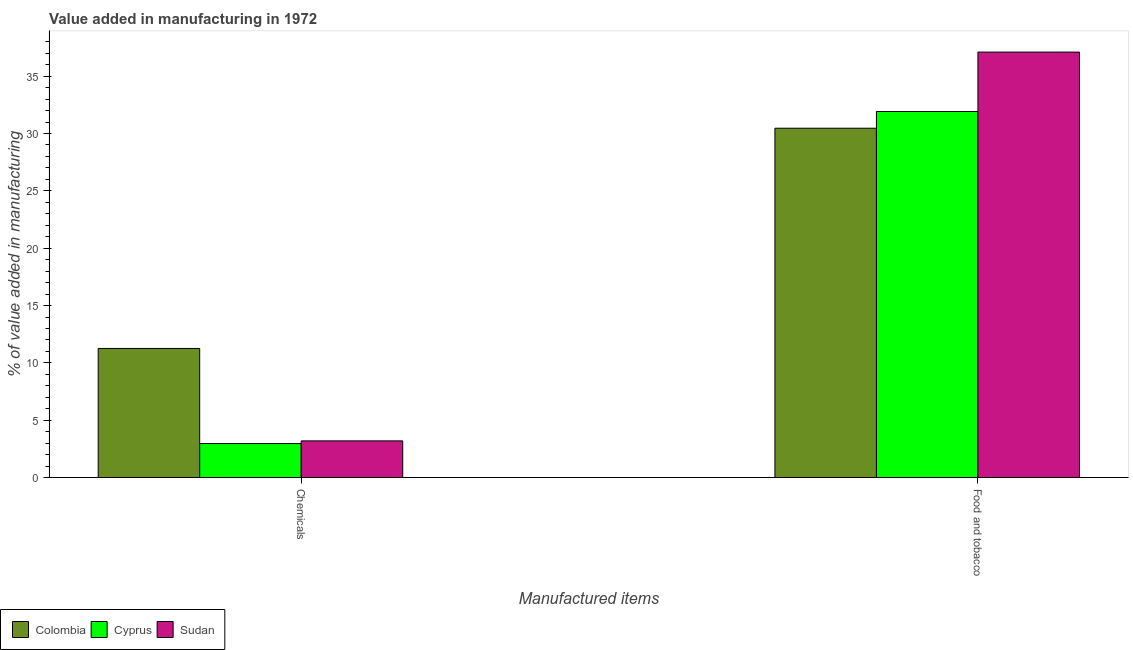How many different coloured bars are there?
Make the answer very short. 3. How many groups of bars are there?
Provide a short and direct response. 2. Are the number of bars on each tick of the X-axis equal?
Your answer should be very brief. Yes. What is the label of the 2nd group of bars from the left?
Offer a very short reply. Food and tobacco. What is the value added by  manufacturing chemicals in Colombia?
Offer a very short reply. 11.26. Across all countries, what is the maximum value added by  manufacturing chemicals?
Provide a succinct answer. 11.26. Across all countries, what is the minimum value added by  manufacturing chemicals?
Offer a very short reply. 2.96. In which country was the value added by manufacturing food and tobacco maximum?
Your answer should be very brief. Sudan. In which country was the value added by  manufacturing chemicals minimum?
Ensure brevity in your answer.  Cyprus. What is the total value added by  manufacturing chemicals in the graph?
Offer a terse response. 17.42. What is the difference between the value added by  manufacturing chemicals in Colombia and that in Sudan?
Give a very brief answer. 8.06. What is the difference between the value added by  manufacturing chemicals in Cyprus and the value added by manufacturing food and tobacco in Sudan?
Your answer should be compact. -34.14. What is the average value added by manufacturing food and tobacco per country?
Ensure brevity in your answer.  33.16. What is the difference between the value added by manufacturing food and tobacco and value added by  manufacturing chemicals in Cyprus?
Keep it short and to the point. 28.96. In how many countries, is the value added by  manufacturing chemicals greater than 16 %?
Keep it short and to the point. 0. What is the ratio of the value added by  manufacturing chemicals in Sudan to that in Colombia?
Provide a succinct answer. 0.28. Is the value added by manufacturing food and tobacco in Colombia less than that in Sudan?
Keep it short and to the point. Yes. In how many countries, is the value added by  manufacturing chemicals greater than the average value added by  manufacturing chemicals taken over all countries?
Offer a very short reply. 1. What does the 1st bar from the left in Chemicals represents?
Ensure brevity in your answer.  Colombia. What does the 1st bar from the right in Food and tobacco represents?
Keep it short and to the point. Sudan. Are all the bars in the graph horizontal?
Your response must be concise. No. How many countries are there in the graph?
Provide a short and direct response. 3. What is the difference between two consecutive major ticks on the Y-axis?
Your response must be concise. 5. Does the graph contain any zero values?
Offer a terse response. No. Does the graph contain grids?
Give a very brief answer. No. How are the legend labels stacked?
Give a very brief answer. Horizontal. What is the title of the graph?
Offer a terse response. Value added in manufacturing in 1972. What is the label or title of the X-axis?
Your answer should be compact. Manufactured items. What is the label or title of the Y-axis?
Your answer should be very brief. % of value added in manufacturing. What is the % of value added in manufacturing of Colombia in Chemicals?
Your response must be concise. 11.26. What is the % of value added in manufacturing in Cyprus in Chemicals?
Provide a short and direct response. 2.96. What is the % of value added in manufacturing in Sudan in Chemicals?
Make the answer very short. 3.2. What is the % of value added in manufacturing in Colombia in Food and tobacco?
Offer a terse response. 30.46. What is the % of value added in manufacturing in Cyprus in Food and tobacco?
Provide a short and direct response. 31.92. What is the % of value added in manufacturing of Sudan in Food and tobacco?
Your response must be concise. 37.1. Across all Manufactured items, what is the maximum % of value added in manufacturing of Colombia?
Provide a short and direct response. 30.46. Across all Manufactured items, what is the maximum % of value added in manufacturing in Cyprus?
Offer a terse response. 31.92. Across all Manufactured items, what is the maximum % of value added in manufacturing in Sudan?
Make the answer very short. 37.1. Across all Manufactured items, what is the minimum % of value added in manufacturing of Colombia?
Give a very brief answer. 11.26. Across all Manufactured items, what is the minimum % of value added in manufacturing of Cyprus?
Your answer should be compact. 2.96. Across all Manufactured items, what is the minimum % of value added in manufacturing of Sudan?
Offer a terse response. 3.2. What is the total % of value added in manufacturing in Colombia in the graph?
Offer a very short reply. 41.72. What is the total % of value added in manufacturing in Cyprus in the graph?
Provide a succinct answer. 34.88. What is the total % of value added in manufacturing of Sudan in the graph?
Your answer should be compact. 40.3. What is the difference between the % of value added in manufacturing of Colombia in Chemicals and that in Food and tobacco?
Make the answer very short. -19.2. What is the difference between the % of value added in manufacturing in Cyprus in Chemicals and that in Food and tobacco?
Offer a terse response. -28.96. What is the difference between the % of value added in manufacturing of Sudan in Chemicals and that in Food and tobacco?
Make the answer very short. -33.9. What is the difference between the % of value added in manufacturing of Colombia in Chemicals and the % of value added in manufacturing of Cyprus in Food and tobacco?
Offer a very short reply. -20.66. What is the difference between the % of value added in manufacturing in Colombia in Chemicals and the % of value added in manufacturing in Sudan in Food and tobacco?
Make the answer very short. -25.84. What is the difference between the % of value added in manufacturing in Cyprus in Chemicals and the % of value added in manufacturing in Sudan in Food and tobacco?
Your answer should be compact. -34.13. What is the average % of value added in manufacturing in Colombia per Manufactured items?
Provide a short and direct response. 20.86. What is the average % of value added in manufacturing of Cyprus per Manufactured items?
Keep it short and to the point. 17.44. What is the average % of value added in manufacturing in Sudan per Manufactured items?
Make the answer very short. 20.15. What is the difference between the % of value added in manufacturing of Colombia and % of value added in manufacturing of Cyprus in Chemicals?
Your response must be concise. 8.29. What is the difference between the % of value added in manufacturing in Colombia and % of value added in manufacturing in Sudan in Chemicals?
Make the answer very short. 8.06. What is the difference between the % of value added in manufacturing of Cyprus and % of value added in manufacturing of Sudan in Chemicals?
Your answer should be compact. -0.24. What is the difference between the % of value added in manufacturing of Colombia and % of value added in manufacturing of Cyprus in Food and tobacco?
Offer a terse response. -1.46. What is the difference between the % of value added in manufacturing of Colombia and % of value added in manufacturing of Sudan in Food and tobacco?
Give a very brief answer. -6.64. What is the difference between the % of value added in manufacturing in Cyprus and % of value added in manufacturing in Sudan in Food and tobacco?
Provide a short and direct response. -5.18. What is the ratio of the % of value added in manufacturing in Colombia in Chemicals to that in Food and tobacco?
Make the answer very short. 0.37. What is the ratio of the % of value added in manufacturing in Cyprus in Chemicals to that in Food and tobacco?
Give a very brief answer. 0.09. What is the ratio of the % of value added in manufacturing of Sudan in Chemicals to that in Food and tobacco?
Your answer should be compact. 0.09. What is the difference between the highest and the second highest % of value added in manufacturing in Colombia?
Ensure brevity in your answer.  19.2. What is the difference between the highest and the second highest % of value added in manufacturing of Cyprus?
Ensure brevity in your answer.  28.96. What is the difference between the highest and the second highest % of value added in manufacturing of Sudan?
Keep it short and to the point. 33.9. What is the difference between the highest and the lowest % of value added in manufacturing in Colombia?
Offer a terse response. 19.2. What is the difference between the highest and the lowest % of value added in manufacturing of Cyprus?
Your answer should be very brief. 28.96. What is the difference between the highest and the lowest % of value added in manufacturing in Sudan?
Your answer should be compact. 33.9. 